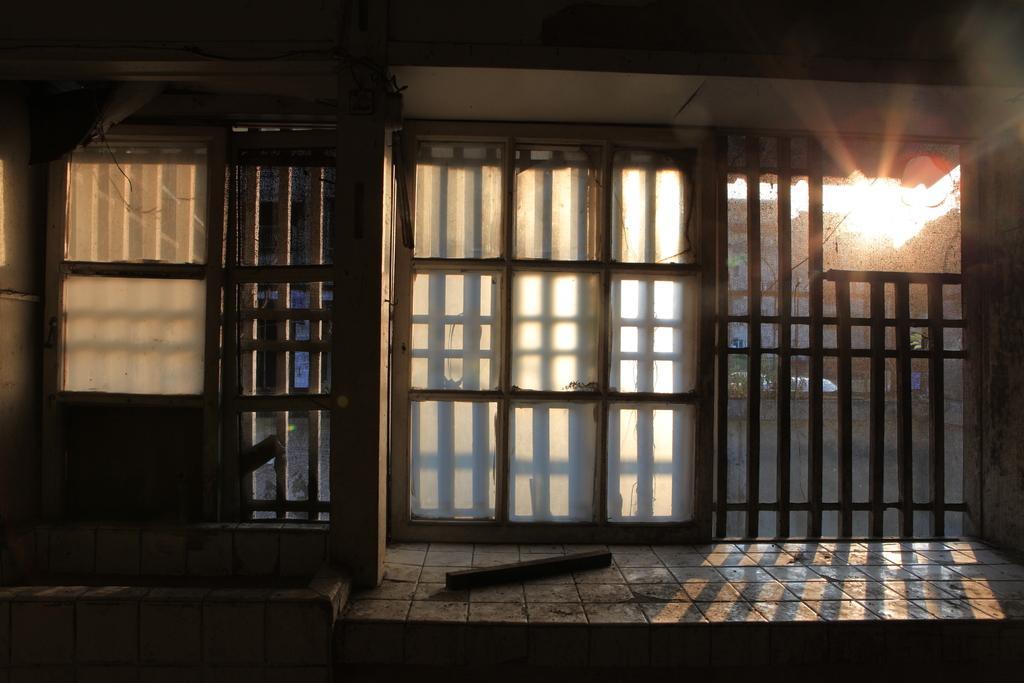Please provide a concise description of this image. In this picture in the center there are windows and behind the windows there are trees. 